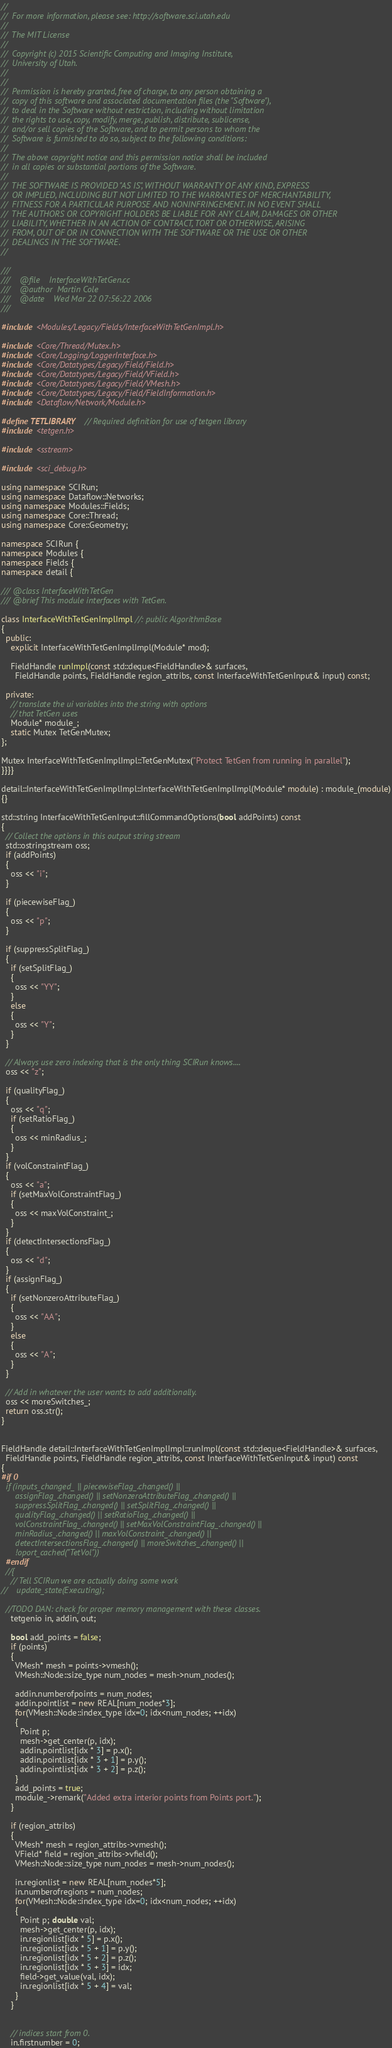<code> <loc_0><loc_0><loc_500><loc_500><_C++_>//
//  For more information, please see: http://software.sci.utah.edu
//
//  The MIT License
//
//  Copyright (c) 2015 Scientific Computing and Imaging Institute,
//  University of Utah.
//
//
//  Permission is hereby granted, free of charge, to any person obtaining a
//  copy of this software and associated documentation files (the "Software"),
//  to deal in the Software without restriction, including without limitation
//  the rights to use, copy, modify, merge, publish, distribute, sublicense,
//  and/or sell copies of the Software, and to permit persons to whom the
//  Software is furnished to do so, subject to the following conditions:
//
//  The above copyright notice and this permission notice shall be included
//  in all copies or substantial portions of the Software.
//
//  THE SOFTWARE IS PROVIDED "AS IS", WITHOUT WARRANTY OF ANY KIND, EXPRESS
//  OR IMPLIED, INCLUDING BUT NOT LIMITED TO THE WARRANTIES OF MERCHANTABILITY,
//  FITNESS FOR A PARTICULAR PURPOSE AND NONINFRINGEMENT. IN NO EVENT SHALL
//  THE AUTHORS OR COPYRIGHT HOLDERS BE LIABLE FOR ANY CLAIM, DAMAGES OR OTHER
//  LIABILITY, WHETHER IN AN ACTION OF CONTRACT, TORT OR OTHERWISE, ARISING
//  FROM, OUT OF OR IN CONNECTION WITH THE SOFTWARE OR THE USE OR OTHER
//  DEALINGS IN THE SOFTWARE.
//

///
///    @file    InterfaceWithTetGen.cc
///    @author  Martin Cole
///    @date    Wed Mar 22 07:56:22 2006
///

#include <Modules/Legacy/Fields/InterfaceWithTetGenImpl.h>

#include <Core/Thread/Mutex.h>
#include <Core/Logging/LoggerInterface.h>
#include <Core/Datatypes/Legacy/Field/Field.h>
#include <Core/Datatypes/Legacy/Field/VField.h>
#include <Core/Datatypes/Legacy/Field/VMesh.h>
#include <Core/Datatypes/Legacy/Field/FieldInformation.h>
#include <Dataflow/Network/Module.h>

#define TETLIBRARY   // Required definition for use of tetgen library
#include <tetgen.h>

#include <sstream>

#include <sci_debug.h>

using namespace SCIRun;
using namespace Dataflow::Networks;
using namespace Modules::Fields;
using namespace Core::Thread;
using namespace Core::Geometry;

namespace SCIRun {
namespace Modules {
namespace Fields {
namespace detail {

/// @class InterfaceWithTetGen
/// @brief This module interfaces with TetGen.

class InterfaceWithTetGenImplImpl //: public AlgorithmBase
{
  public:
    explicit InterfaceWithTetGenImplImpl(Module* mod);

    FieldHandle runImpl(const std::deque<FieldHandle>& surfaces,
      FieldHandle points, FieldHandle region_attribs, const InterfaceWithTetGenInput& input) const;

  private:
    // translate the ui variables into the string with options
    // that TetGen uses
    Module* module_;
    static Mutex TetGenMutex;
};

Mutex InterfaceWithTetGenImplImpl::TetGenMutex("Protect TetGen from running in parallel");
}}}}

detail::InterfaceWithTetGenImplImpl::InterfaceWithTetGenImplImpl(Module* module) : module_(module)
{}

std::string InterfaceWithTetGenInput::fillCommandOptions(bool addPoints) const
{
  // Collect the options in this output string stream
  std::ostringstream oss;
  if (addPoints)
  {
    oss << "i";
  }

  if (piecewiseFlag_)
  {
    oss << "p";
  }

  if (suppressSplitFlag_)
  {
    if (setSplitFlag_)
    {
      oss << "YY";
    }
    else
    {
      oss << "Y";
    }
  }

  // Always use zero indexing that is the only thing SCIRun knows....
  oss << "z";

  if (qualityFlag_)
  {
    oss << "q";
    if (setRatioFlag_)
    {
      oss << minRadius_;
    }
  }
  if (volConstraintFlag_)
  {
    oss << "a";
    if (setMaxVolConstraintFlag_)
    {
      oss << maxVolConstraint_;
    }
  }
  if (detectIntersectionsFlag_)
  {
    oss << "d";
  }
  if (assignFlag_)
  {
    if (setNonzeroAttributeFlag_)
    {
      oss << "AA";
    }
    else
    {
      oss << "A";
    }
  }

  // Add in whatever the user wants to add additionally.
  oss << moreSwitches_;
  return oss.str();
}


FieldHandle detail::InterfaceWithTetGenImplImpl::runImpl(const std::deque<FieldHandle>& surfaces,
  FieldHandle points, FieldHandle region_attribs, const InterfaceWithTetGenInput& input) const
{
#if 0
  if (inputs_changed_ || piecewiseFlag_.changed() ||
      assignFlag_.changed() || setNonzeroAttributeFlag_.changed() ||
      suppressSplitFlag_.changed() || setSplitFlag_.changed() ||
      qualityFlag_.changed() || setRatioFlag_.changed() ||
      volConstraintFlag_.changed() || setMaxVolConstraintFlag_.changed() ||
      minRadius_.changed() || maxVolConstraint_.changed() ||
      detectIntersectionsFlag_.changed() || moreSwitches_.changed() ||
      !oport_cached("TetVol"))
  #endif
  //{
    // Tell SCIRun we are actually doing some work
//    update_state(Executing);

  //TODO DAN: check for proper memory management with these classes.
    tetgenio in, addin, out;

    bool add_points = false;
    if (points)
    {
      VMesh* mesh = points->vmesh();
      VMesh::Node::size_type num_nodes = mesh->num_nodes();

      addin.numberofpoints = num_nodes;
      addin.pointlist = new REAL[num_nodes*3];
      for(VMesh::Node::index_type idx=0; idx<num_nodes; ++idx)
      {
        Point p;
        mesh->get_center(p, idx);
        addin.pointlist[idx * 3] = p.x();
        addin.pointlist[idx * 3 + 1] = p.y();
        addin.pointlist[idx * 3 + 2] = p.z();
      }
      add_points = true;
      module_->remark("Added extra interior points from Points port.");
    }

    if (region_attribs)
    {
      VMesh* mesh = region_attribs->vmesh();
      VField* field = region_attribs->vfield();
      VMesh::Node::size_type num_nodes = mesh->num_nodes();

      in.regionlist = new REAL[num_nodes*5];
      in.numberofregions = num_nodes;
      for(VMesh::Node::index_type idx=0; idx<num_nodes; ++idx)
      {
        Point p; double val;
        mesh->get_center(p, idx);
        in.regionlist[idx * 5] = p.x();
        in.regionlist[idx * 5 + 1] = p.y();
        in.regionlist[idx * 5 + 2] = p.z();
        in.regionlist[idx * 5 + 3] = idx;
        field->get_value(val, idx);
        in.regionlist[idx * 5 + 4] = val;
      }
    }


    // indices start from 0.
    in.firstnumber = 0;</code> 